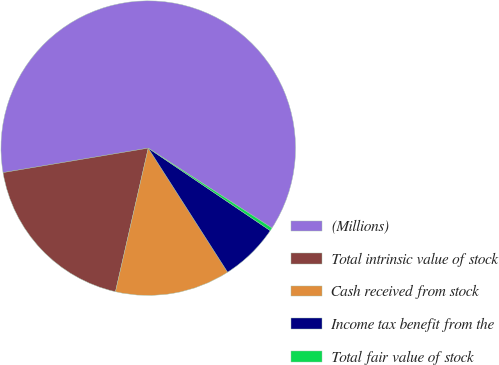Convert chart to OTSL. <chart><loc_0><loc_0><loc_500><loc_500><pie_chart><fcel>(Millions)<fcel>Total intrinsic value of stock<fcel>Cash received from stock<fcel>Income tax benefit from the<fcel>Total fair value of stock<nl><fcel>61.78%<fcel>18.77%<fcel>12.63%<fcel>6.48%<fcel>0.34%<nl></chart> 